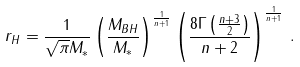Convert formula to latex. <formula><loc_0><loc_0><loc_500><loc_500>r _ { H } = \frac { 1 } { \sqrt { \pi } M _ { * } } \left ( \frac { M _ { B H } } { M _ { * } } \right ) ^ { \frac { 1 } { n + 1 } } \left ( \frac { 8 \Gamma \left ( \frac { n + 3 } { 2 } \right ) } { n + 2 } \right ) ^ { \frac { 1 } { n + 1 } } \, .</formula> 